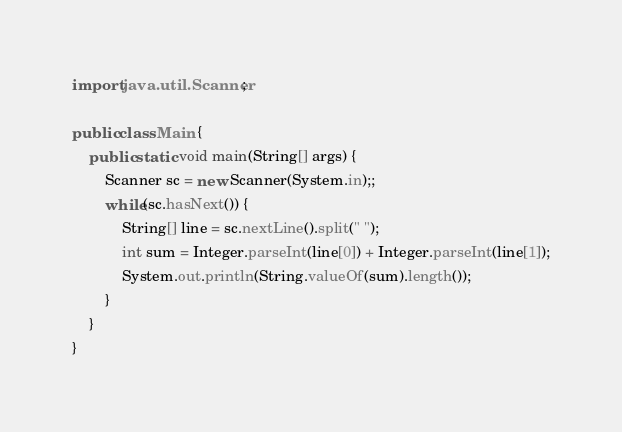<code> <loc_0><loc_0><loc_500><loc_500><_Java_>import java.util.Scanner;

public class Main {
    public static void main(String[] args) {
        Scanner sc = new Scanner(System.in);;
        while(sc.hasNext()) {
            String[] line = sc.nextLine().split(" ");
            int sum = Integer.parseInt(line[0]) + Integer.parseInt(line[1]);
            System.out.println(String.valueOf(sum).length());
        }
    }
}</code> 